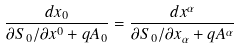<formula> <loc_0><loc_0><loc_500><loc_500>\frac { d x _ { 0 } } { \partial S _ { 0 } / \partial x ^ { 0 } + q A _ { 0 } } = \frac { d x ^ { \alpha } } { \partial S _ { 0 } / \partial x _ { \alpha } + q A ^ { \alpha } }</formula> 